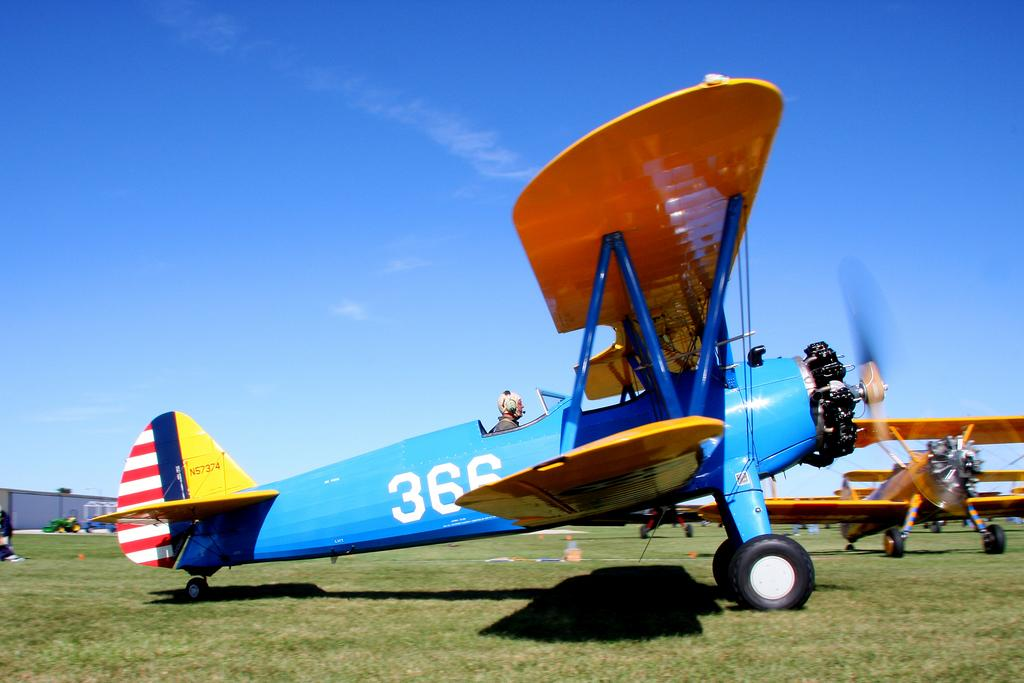What type of vehicles are on the ground in the image? There are aircraft on the ground in the image. What is the person in the image doing? The person is sitting on the ground. Can you describe any identifying features on the aircraft? There is a number on the aircraft. What type of surface is the person sitting on? There is grass on the ground. What can be seen in the background of the image? The sky is visible in the background. How many balls can be seen in the image? There are no balls present in the image. What is the person's uncle doing in the image? There is no mention of an uncle in the image, so it cannot be determined what they might be doing. 